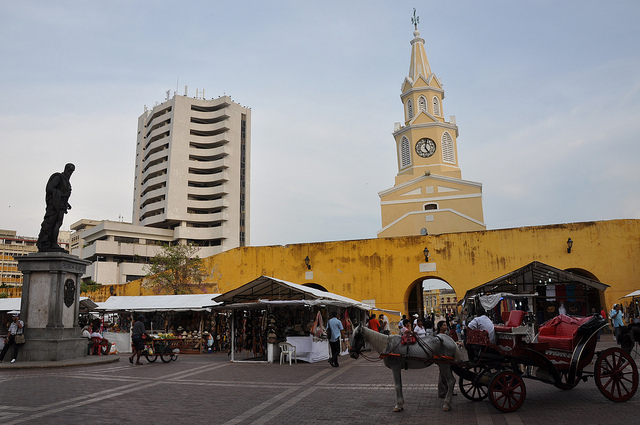<image>What city is this? I don't know what city this is. The given answers suggest various locations around the world. What city is this? I am not sure what city is this. It can be Brazil, Italy, Boston, Frankfort, City in Central or South America, Detroit, London, or Moscow. 